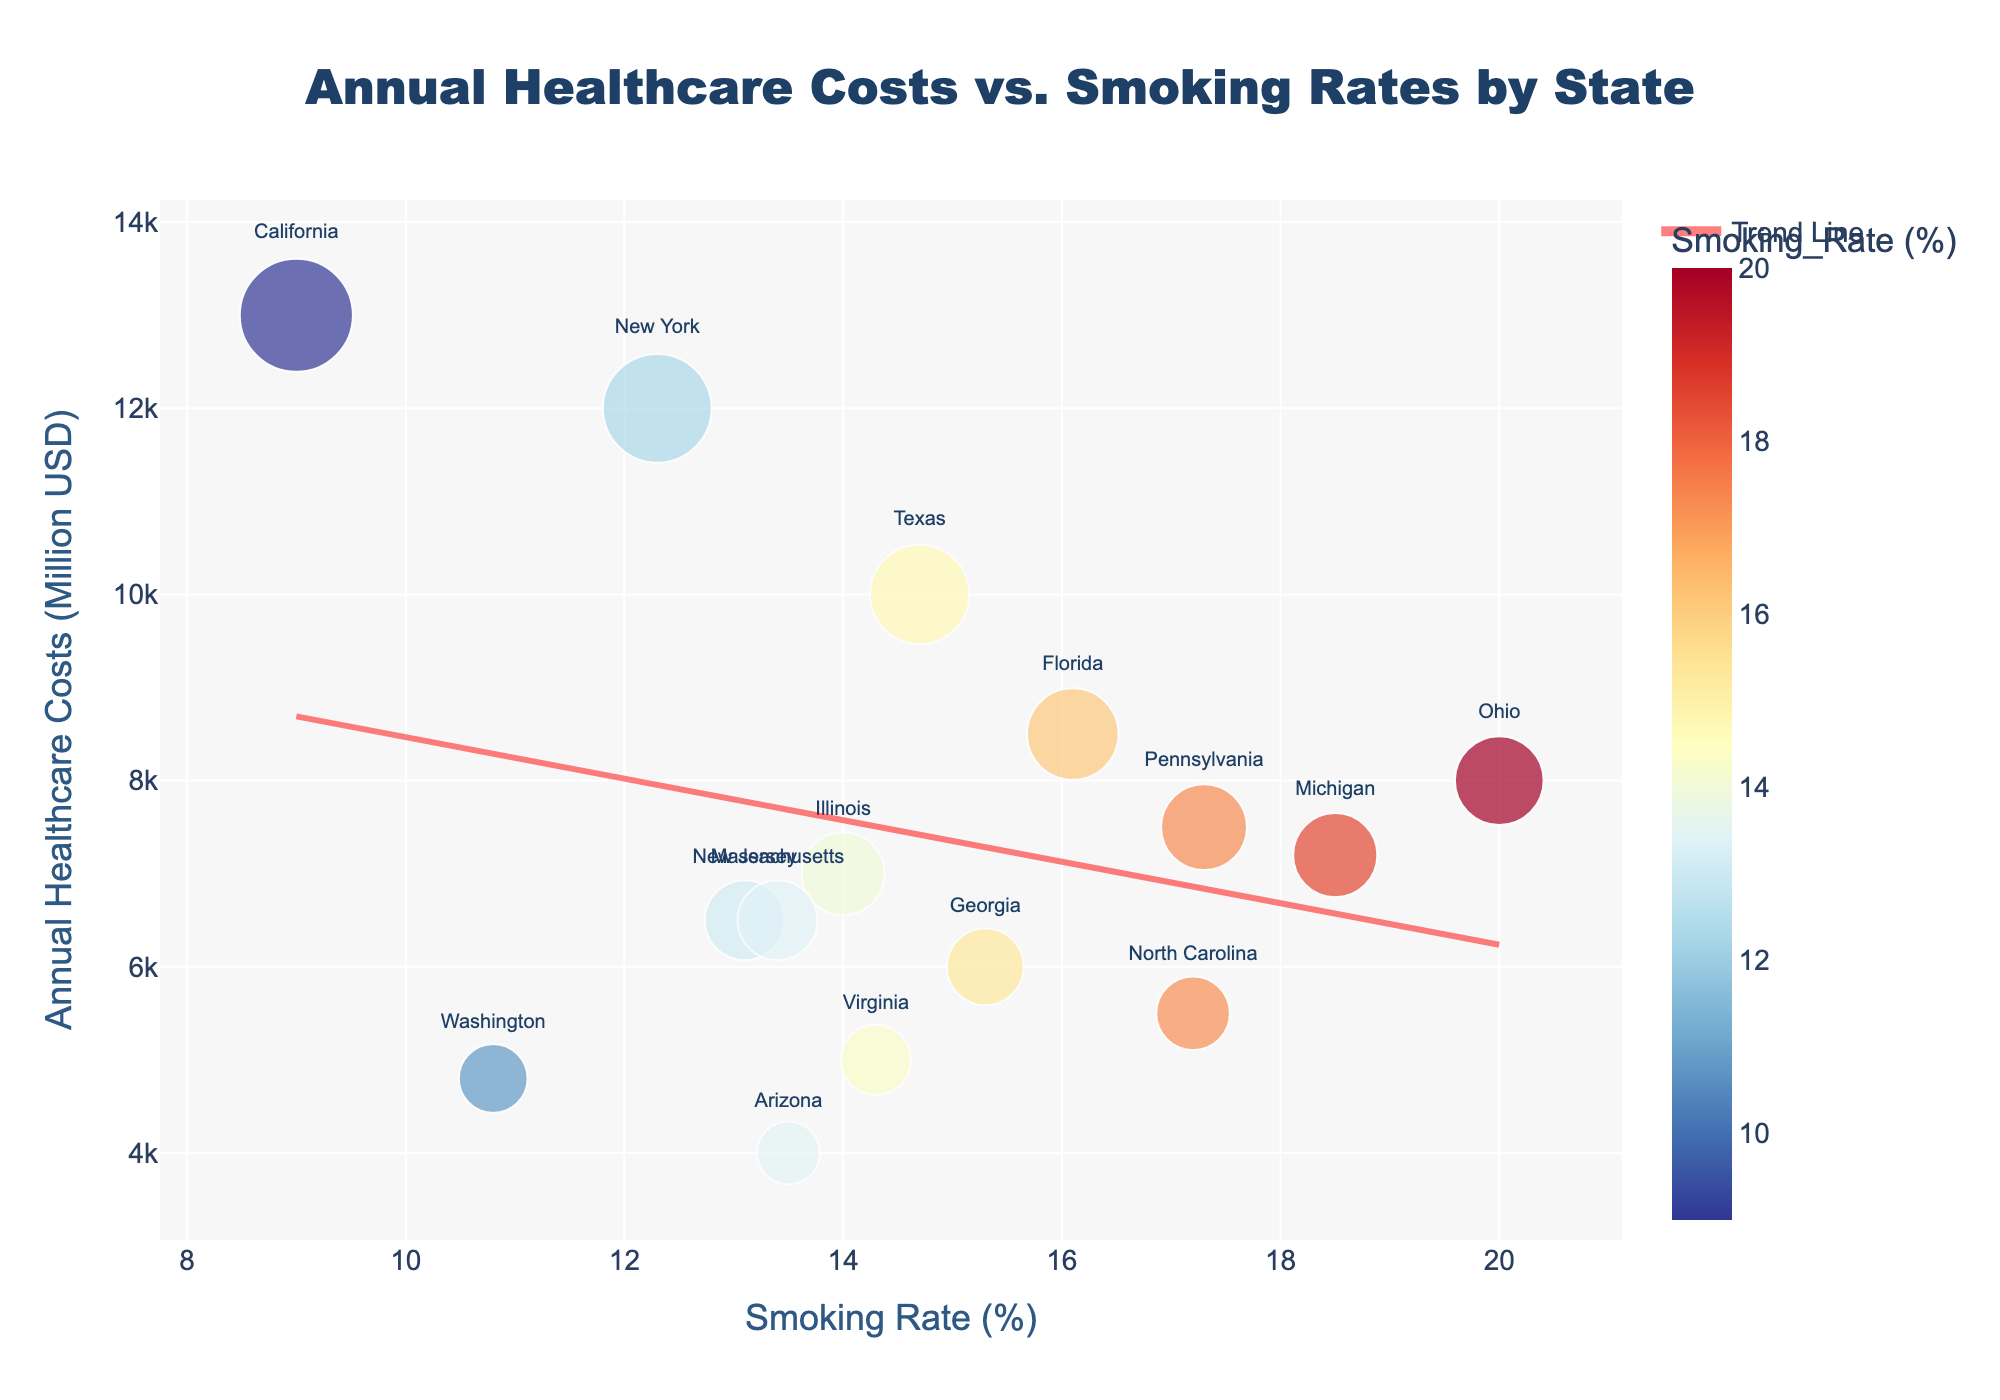What state's the smoking rate is closest to the average smoking rate in the dataset? First, calculate the average smoking rate: (9.0 + 14.7 + 12.3 + 16.1 + 14.0 + 17.3 + 20.0 + 15.3 + 17.2 + 18.5 + 13.1 + 14.3 + 10.8 + 13.5 + 13.4)/15 ≈ 14.4%. The smoking rate of Virginia (14.3%) is closest to this average.
Answer: Virginia What is the general trend between smoking rates and annual healthcare costs across the states? Observing the trend line added to the scatter plot, we see a positive slope indicating that, generally, states with higher smoking rates tend to have higher annual healthcare costs.
Answer: Positive correlation Which state has the highest annual healthcare costs and what is their smoking rate? By looking at the scatter points and their annotations, California is identified as the state with the highest annual healthcare costs at 13,000 million USD. Its smoking rate is 9.0%.
Answer: California, 9.0% Is there an outlier with a high smoking rate but lower-than-expected healthcare costs? Which is it? By examining the scatter plot and the trend line, Ohio stands out with a high smoking rate (20.0%) but an annual healthcare cost (8,000 million USD) that isn't comparatively as high.
Answer: Ohio How many states have smoking rates higher than 15%? Counting the states on the scatter plot with smoking rates above 15%: Florida, Pennsylvania, Ohio, North Carolina, and Michigan.
Answer: 5 Which state has the lowest smoking rate? On the scatter plot, the state with the lowest smoking rate is California, indicated at 9.0%.
Answer: California Comparing New York and Virginia, which state has higher annual healthcare costs? New York has an annual healthcare cost of 12,000 million USD, while Virginia has 5,000 million USD. Hence, New York is higher.
Answer: New York What's the approximate difference in healthcare costs between Ohio and New Jersey? Ohio's healthcare costs are 8,000 million USD, and New Jersey's are 6,500 million USD, resulting in a difference of 1,500 million USD.
Answer: 1,500 million USD Does the state with the lowest healthcare costs also have one of the lowest smoking rates? The lowest healthcare costs are in Arizona, at 4,000 million USD. Arizona's smoking rate is 13.5%, which is not among the lowest rates.
Answer: No 